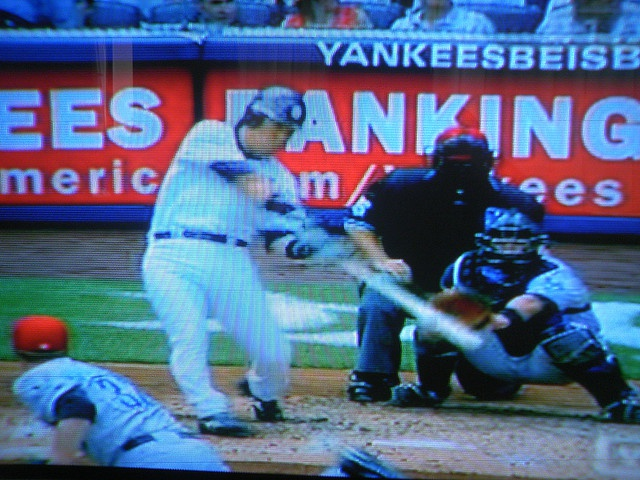Describe the objects in this image and their specific colors. I can see people in blue and lightblue tones, people in blue, black, navy, and lightblue tones, people in blue, black, navy, and darkblue tones, people in blue, lightblue, and gray tones, and people in blue, lightblue, and gray tones in this image. 